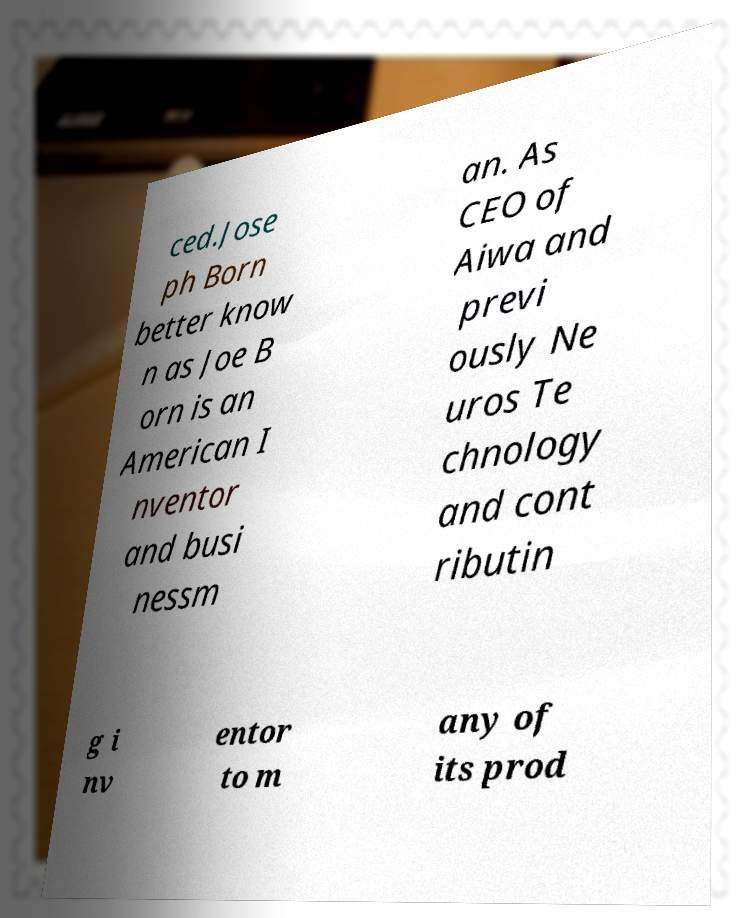I need the written content from this picture converted into text. Can you do that? ced.Jose ph Born better know n as Joe B orn is an American I nventor and busi nessm an. As CEO of Aiwa and previ ously Ne uros Te chnology and cont ributin g i nv entor to m any of its prod 